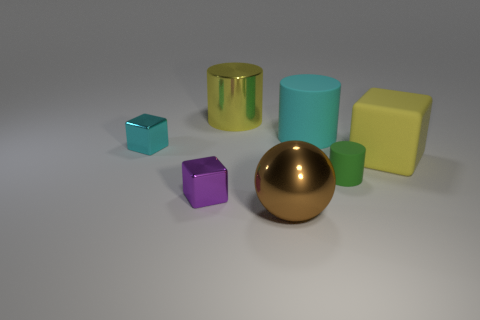Add 2 big yellow cylinders. How many objects exist? 9 Subtract all blocks. How many objects are left? 4 Add 6 green objects. How many green objects are left? 7 Add 3 purple objects. How many purple objects exist? 4 Subtract 0 red cylinders. How many objects are left? 7 Subtract all tiny yellow spheres. Subtract all yellow rubber blocks. How many objects are left? 6 